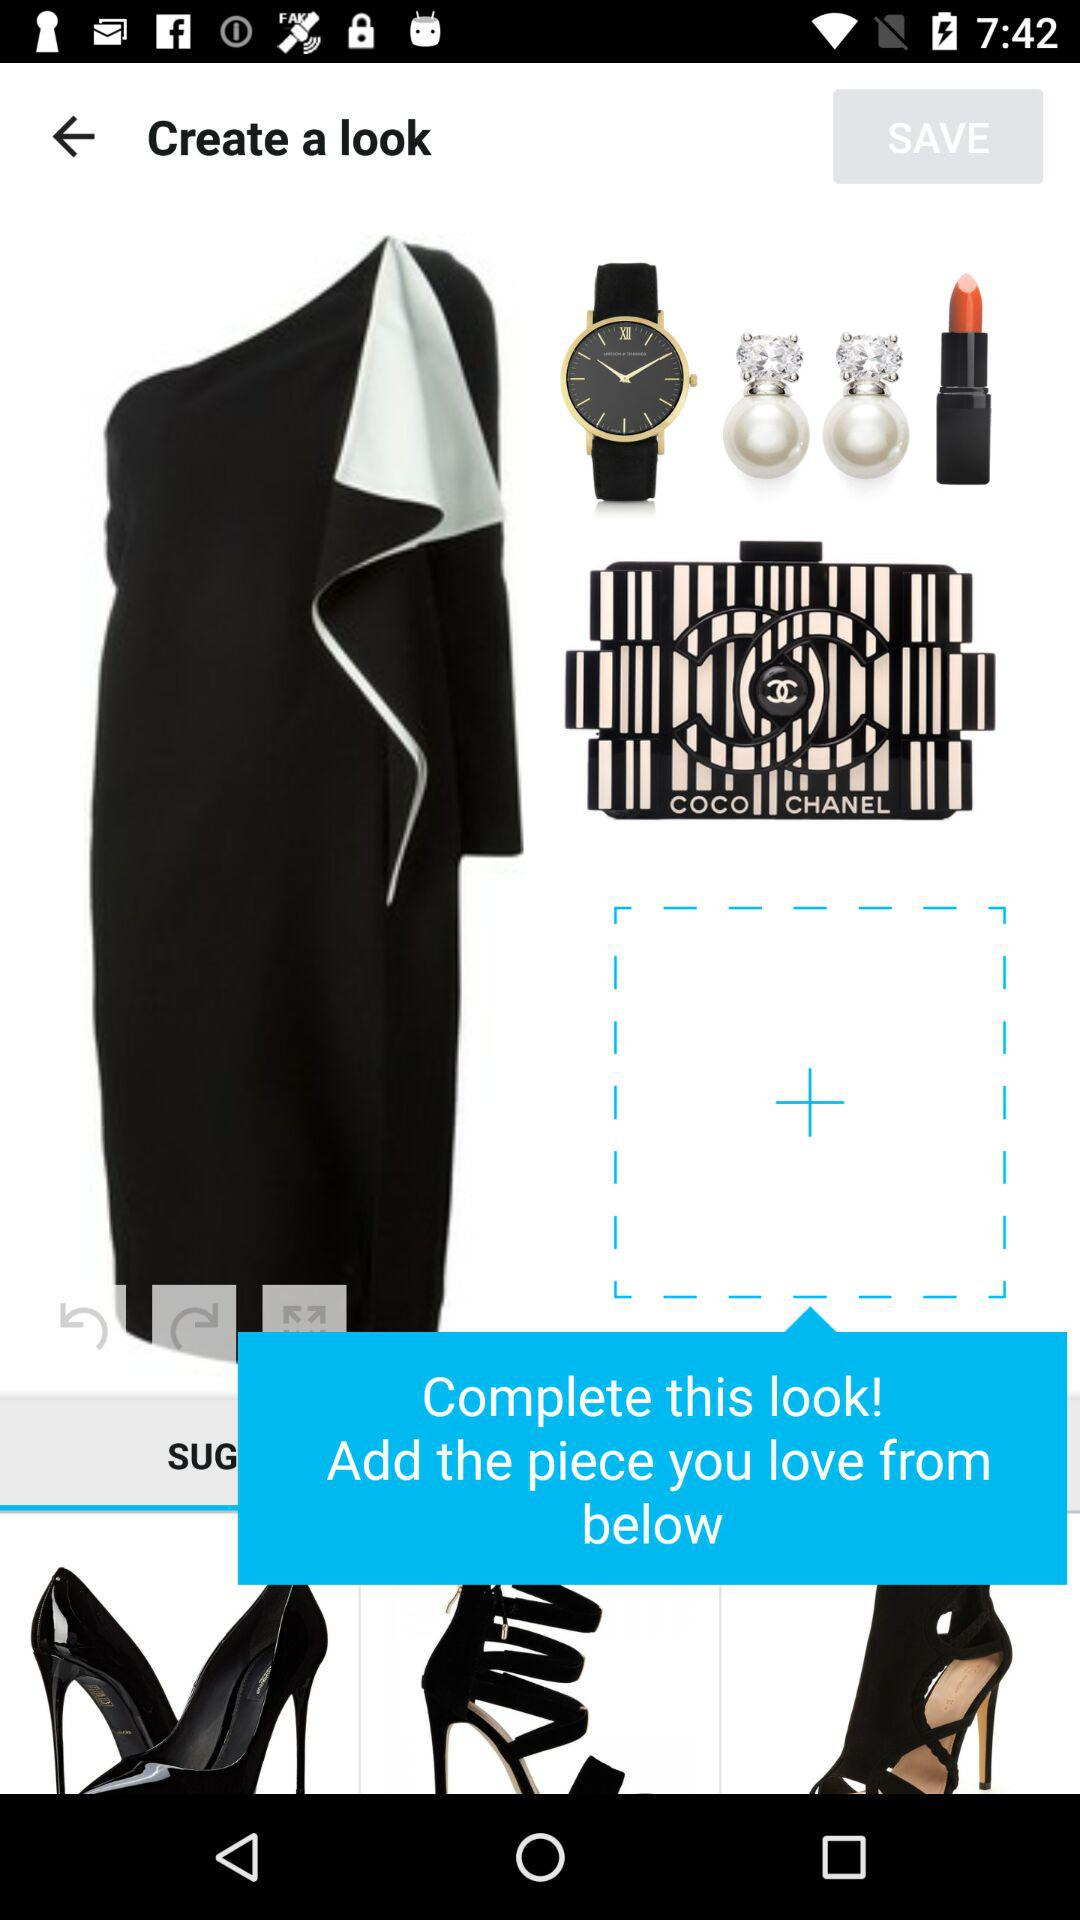How many suggested items are there?
Answer the question using a single word or phrase. 3 